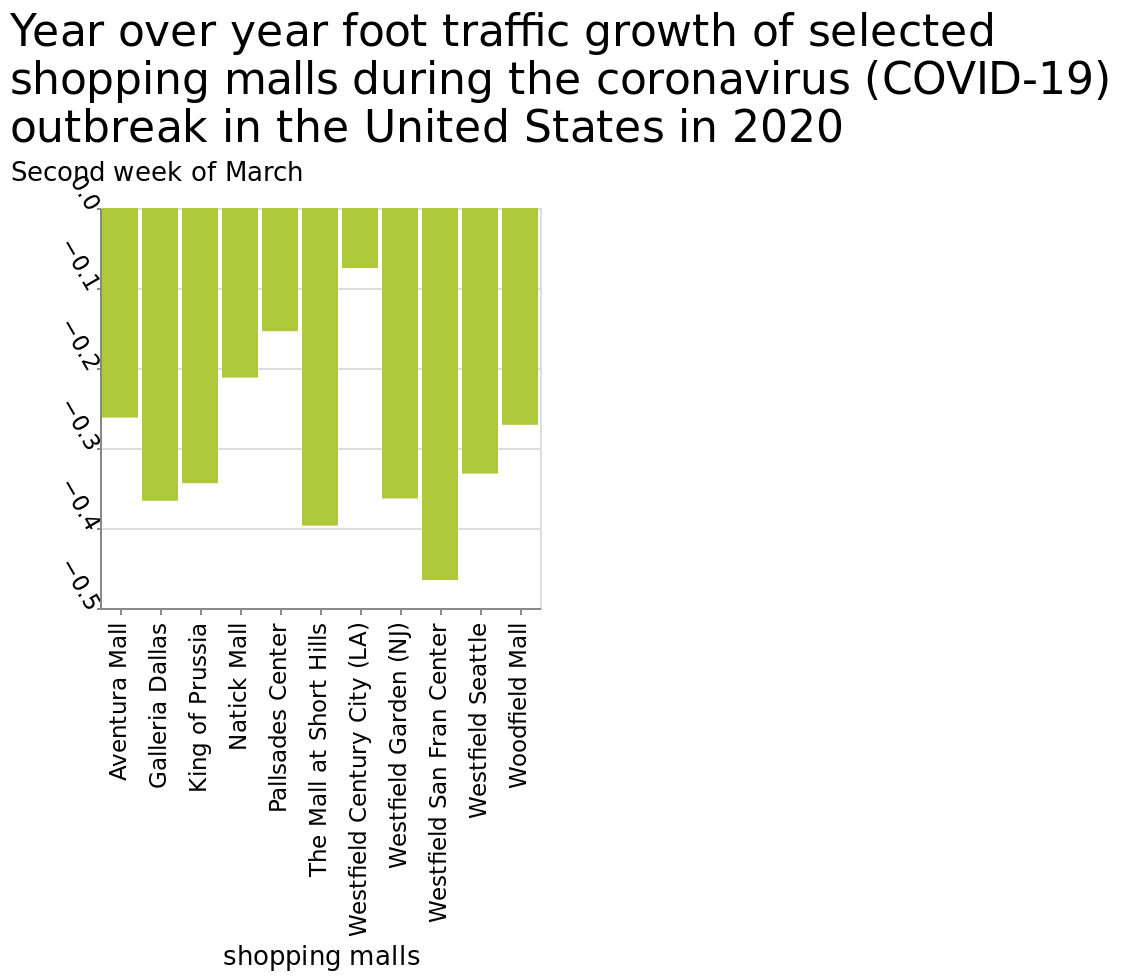<image>
What was the overall trend in growth for the shopping centres?  The overall trend in growth for the shopping centres was negative, as all the figures are below zero. What is plotted on the x-axis?  The x-axis represents the shopping malls. 